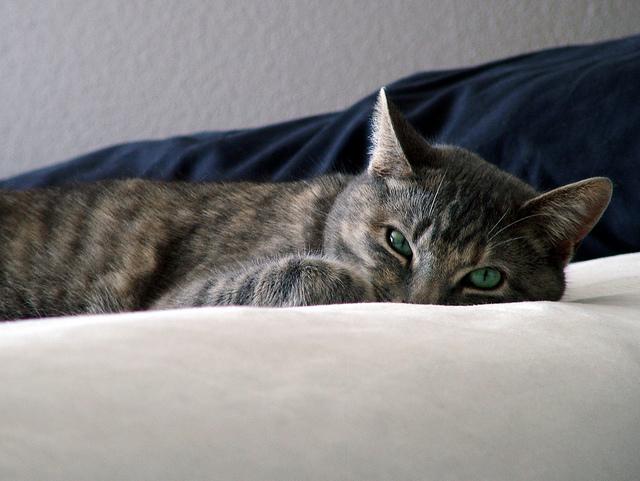Is this a short-haired cat?
Write a very short answer. Yes. Was the cat asleep or ready to pounce?
Be succinct. Asleep. Does this cat have beautiful eyes?
Write a very short answer. Yes. 